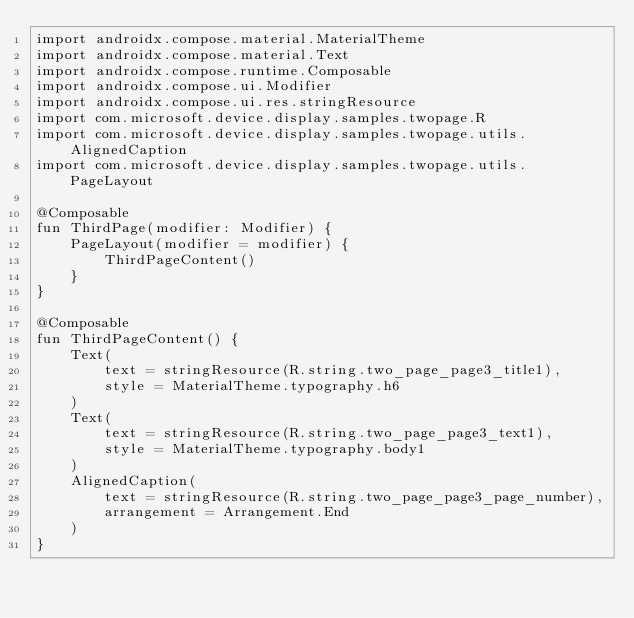<code> <loc_0><loc_0><loc_500><loc_500><_Kotlin_>import androidx.compose.material.MaterialTheme
import androidx.compose.material.Text
import androidx.compose.runtime.Composable
import androidx.compose.ui.Modifier
import androidx.compose.ui.res.stringResource
import com.microsoft.device.display.samples.twopage.R
import com.microsoft.device.display.samples.twopage.utils.AlignedCaption
import com.microsoft.device.display.samples.twopage.utils.PageLayout

@Composable
fun ThirdPage(modifier: Modifier) {
    PageLayout(modifier = modifier) {
        ThirdPageContent()
    }
}

@Composable
fun ThirdPageContent() {
    Text(
        text = stringResource(R.string.two_page_page3_title1),
        style = MaterialTheme.typography.h6
    )
    Text(
        text = stringResource(R.string.two_page_page3_text1),
        style = MaterialTheme.typography.body1
    )
    AlignedCaption(
        text = stringResource(R.string.two_page_page3_page_number),
        arrangement = Arrangement.End
    )
}
</code> 